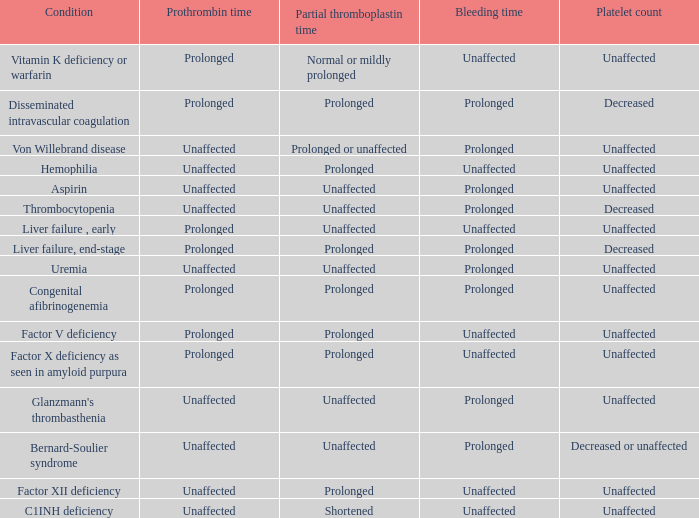Which hemorrhage is associated with the condition of congenital afibrinogenemia? Prolonged. 